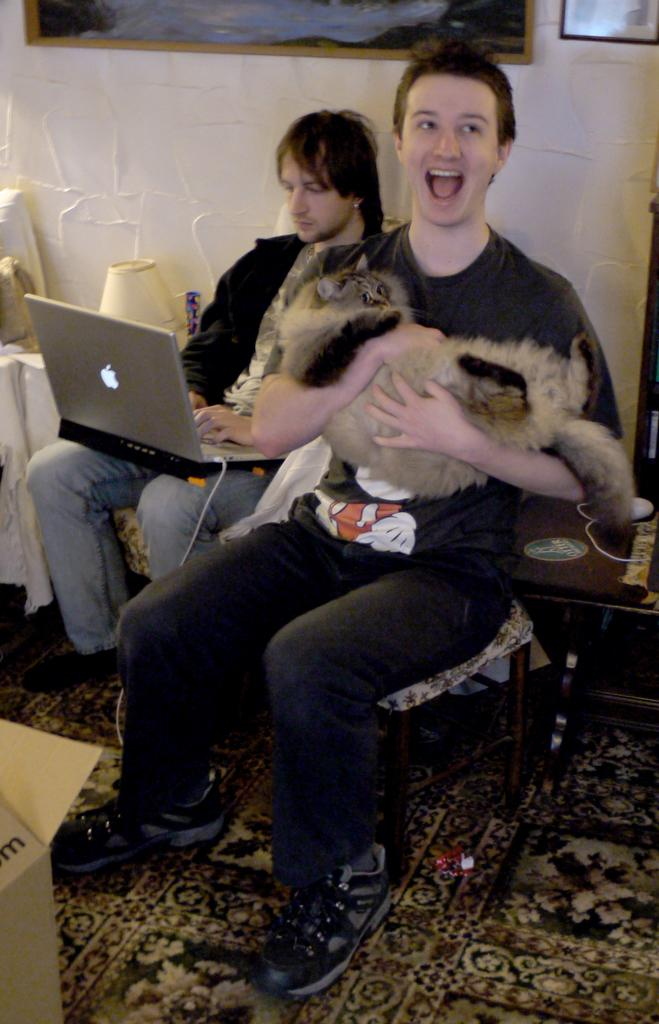What is the person in the image wearing? The person is wearing a grey shirt in the image. What is the person holding in the image? The person is holding a cat in the image. Can you describe the activity of the second person in the image? The second person is operating a laptop in the image. What type of destruction is the team causing in the image? There is no team or destruction present in the image. 